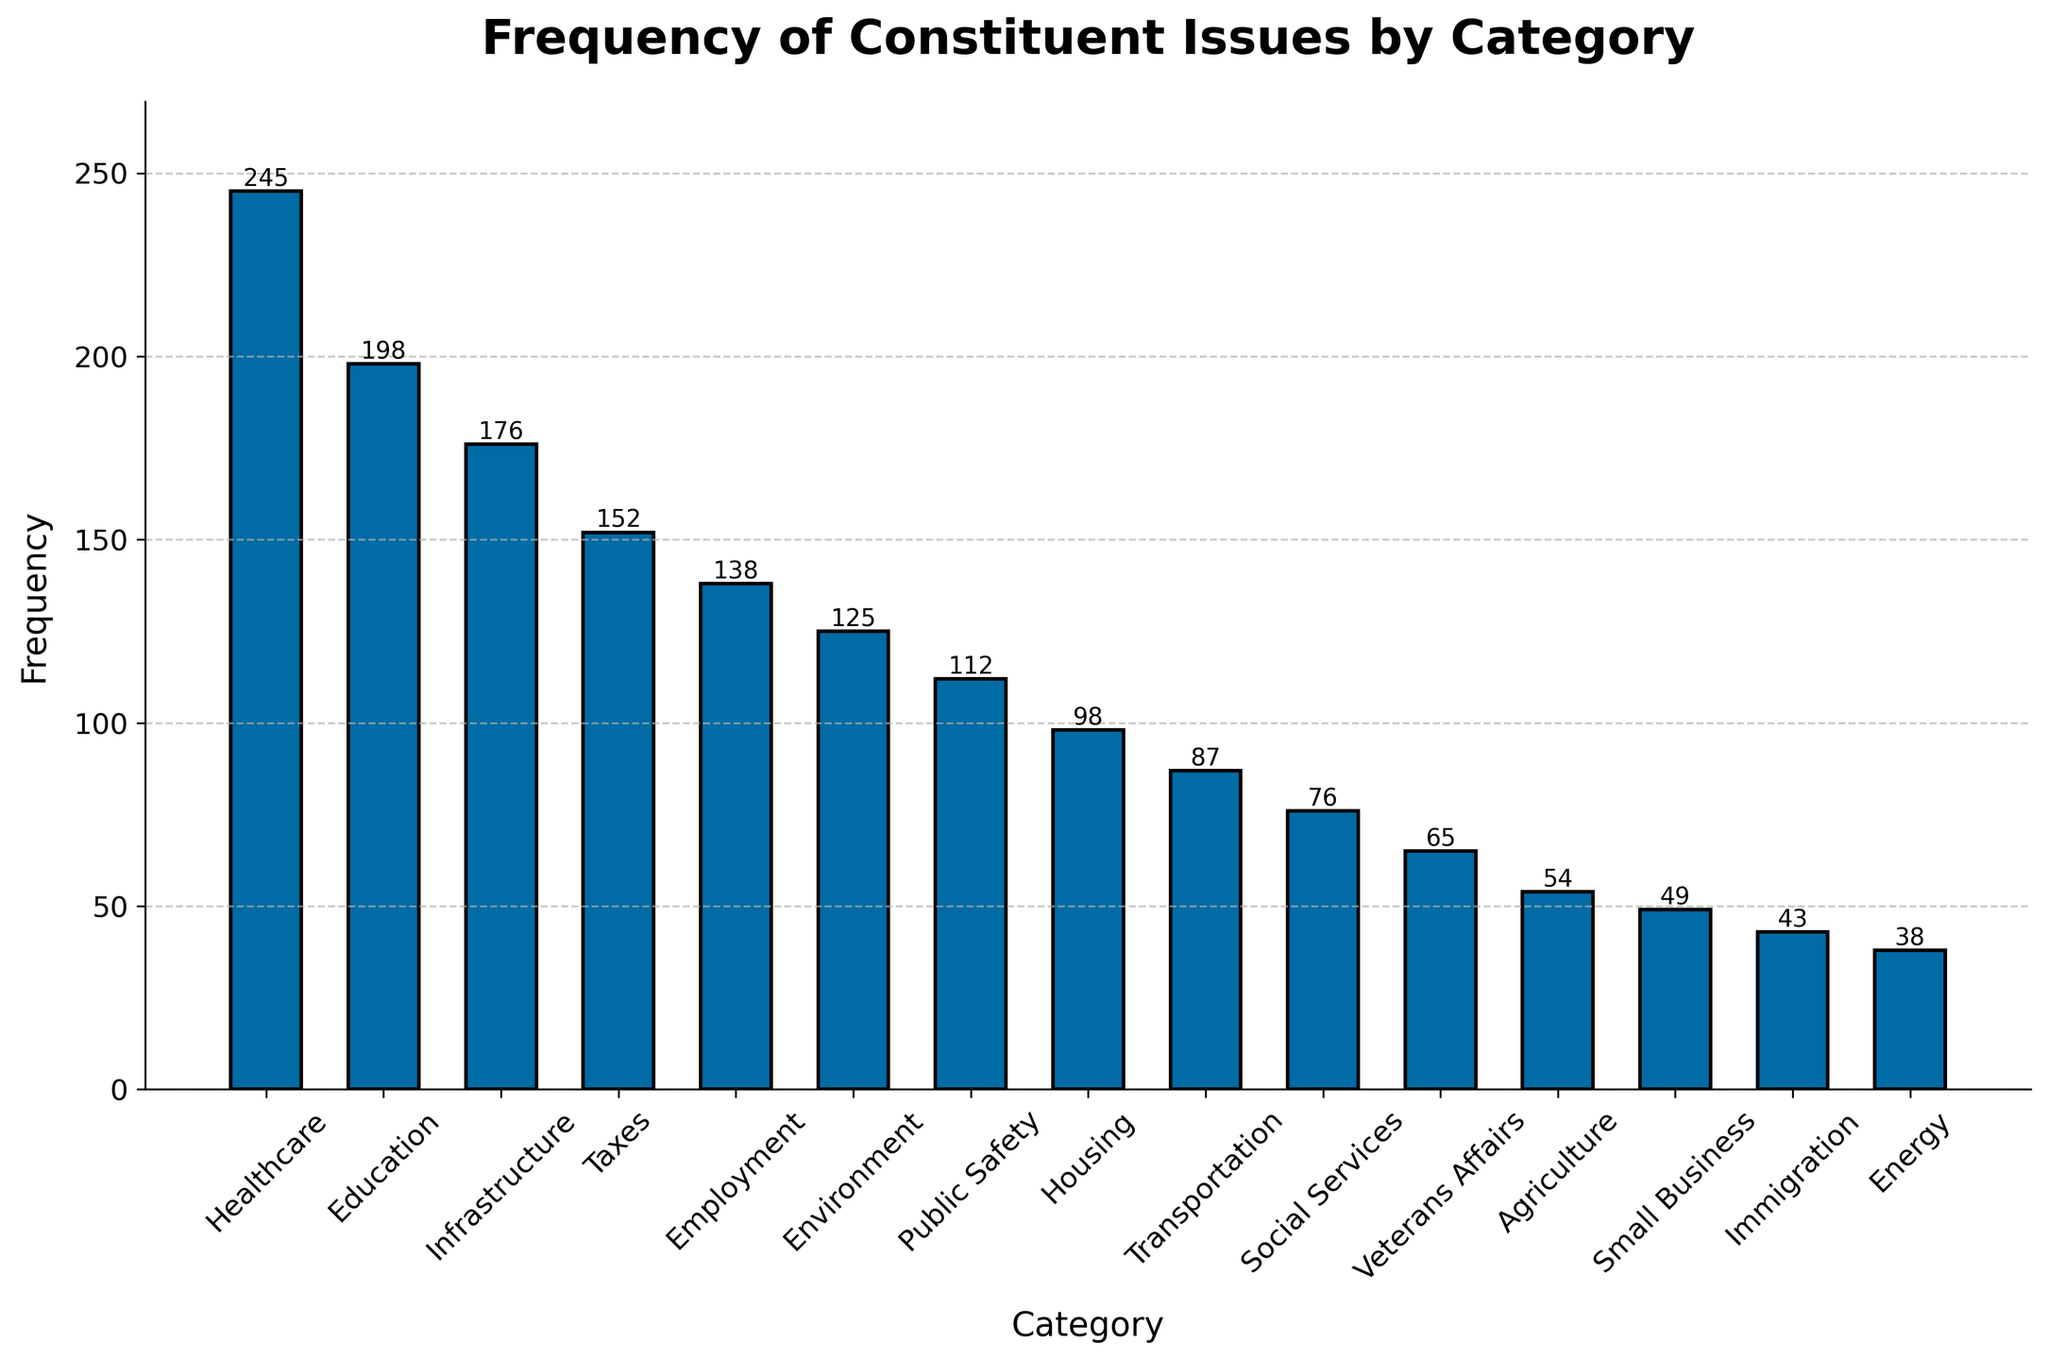Which category has the highest frequency? The category with the highest frequency is identified by the tallest bar on the plot. In this case, Healthcare has the tallest bar, indicating it has the highest frequency.
Answer: Healthcare What is the frequency difference between Education and Employment? To find the frequency difference, subtract the frequency of Employment from that of Education. The frequency of Education is 198 and Employment is 138. So, 198 - 138 = 60.
Answer: 60 Which category has a lower frequency, Energy or Agriculture? Compare the heights of the bars representing these two categories. Energy has a frequency of 38 while Agriculture has a frequency of 54. Thus, Energy has a lower frequency.
Answer: Energy What is the combined frequency of the top three categories? The top three categories are Healthcare, Education, and Infrastructure. Their frequencies are 245, 198, and 176, respectively. Add these values: 245 + 198 + 176 = 619.
Answer: 619 How many categories have a frequency higher than 100? Count the number of bars that extend above the 100 mark on the y-axis. These are Healthcare, Education, Infrastructure, Taxes, Employment, Environment, and Public Safety, totaling 7 categories.
Answer: 7 Which category has a frequency closest to 100? Identify the bar whose height is nearest to the 100 mark. Housing has a frequency of 98, which is closest to 100.
Answer: Housing What is the average frequency of the categories listed? Add all the frequencies together and divide by the number of categories. Total frequency is \(245 + 198 + 176 + 152 + 138 + 125 + 112 + 98 + 87 + 76 + 65 + 54 + 49 + 43 + 38 = 1658\). There are 15 categories, so the average is \(1658 / 15 = 110.53\).
Answer: 110.53 What is the frequency range of the categories? Subtract the smallest frequency from the largest frequency. The largest is Healthcare at 245 and the smallest is Energy at 38. So, 245 - 38 = 207.
Answer: 207 How much higher is the frequency of Healthcare compared to Transportation? Find the difference between the frequencies of these two categories. Healthcare has 245 and Transportation has 87. So, 245 - 87 = 158.
Answer: 158 What is the median frequency of the categories listed? First, list the frequencies in ascending order: 38, 43, 49, 54, 65, 76, 87, 98, 112, 125, 138, 152, 176, 198, 245. The median is the middle value in this sequence, which is the 8th value (98) since there are 15 numbers.
Answer: 98 